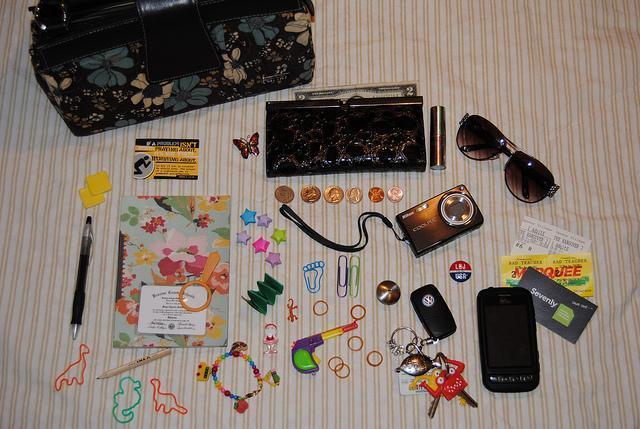What brand of car does this person drive?
Pick the correct solution from the four options below to address the question.
Options: Volkswagen, honda, toyota, ford. Volkswagen. 